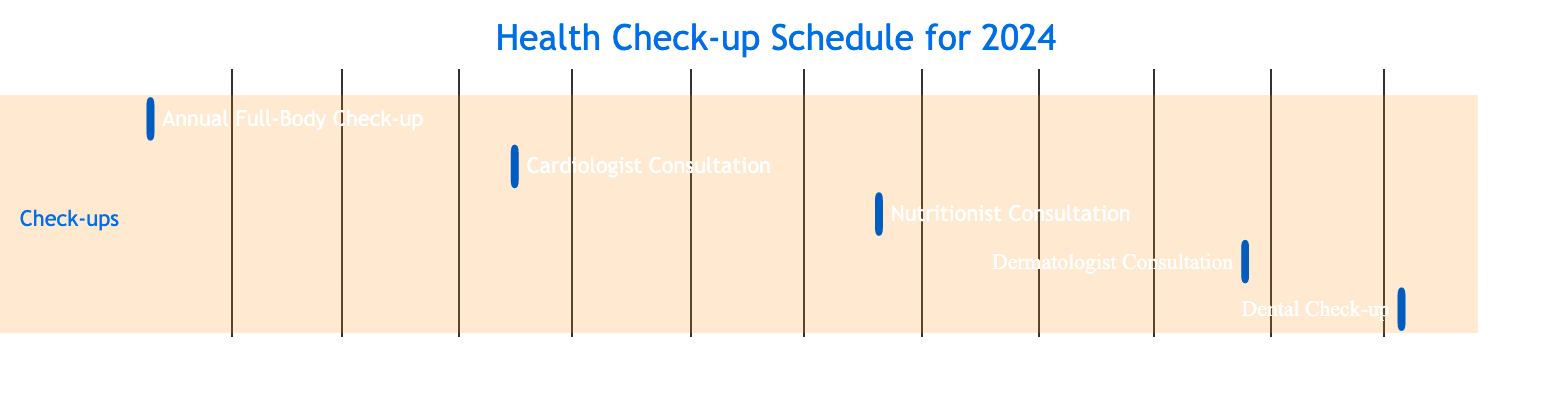What is the first scheduled health check-up? The diagram lists the tasks in chronological order. The first task is the Annual Full-Body Check-up, which is scheduled for January 10, 2024.
Answer: Annual Full-Body Check-up How many consultations are scheduled for the year? By counting the tasks in the diagram, there are five tasks listed for the health check-up schedule, which include both consultations and check-ups.
Answer: 5 What is the date of the Nutritionist Consultation? The diagram indicates that the Nutritionist Consultation is scheduled for July 20, 2024, as identified in the task list.
Answer: July 20, 2024 Which consultation is the last one of the year? The last task listed in the diagram is the Dental Check-up, which occurs on December 5, 2024.
Answer: Dental Check-up Are any health check-ups scheduled in the third quarter? The available tasks show that there are no scheduled check-ups for the third quarter of the year (Q3) since all tasks take place in the first, second, fourth quarter, thus making it a reasoning question regarding quarterly distribution.
Answer: No What is the duration of the Cardiologist Consultation? Each task in the diagram's schedule is shown as having a duration of 1 day, including the Cardiologist Consultation specifically listed for April 15, 2024.
Answer: 1 day Which check-up occurs in the fourth quarter? The diagram shows that the Dermatologist Consultation is the only check-up scheduled in the fourth quarter, occurring on October 25, 2024.
Answer: Dermatologist Consultation What is the gap between the Annual Full-Body Check-up and the Cardiologist Consultation? The first check-up is on January 10, 2024, and the Cardiologist Consultation is on April 15, 2024. To find the gap, we calculate the number of days between those two dates. There are 95 days in between.
Answer: 95 days 